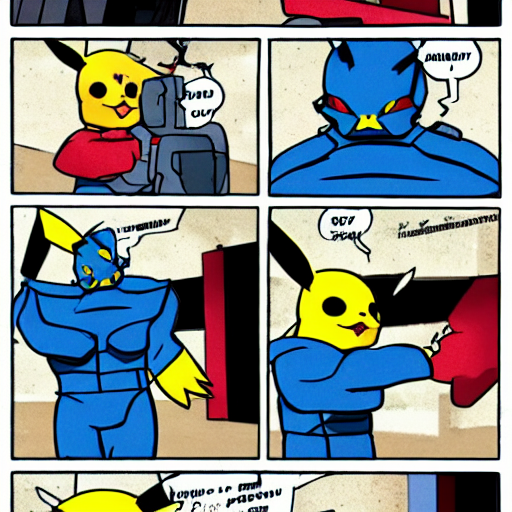Can you describe the style of artwork in this image? This image appears to have adopted a style that closely resembles traditional comic book art, characterized by its bold lines, vivid colors, and dynamic characters. It features a paneled layout typical of comic strips, with speech bubbles indicating dialogue, contributing to storytelling within a single frame or a sequence of frames. What do the color choices in the image suggest about the mood or theme? The color palette emphasizes primary colors like red, blue, and yellow, which are often used in superhero comics to convey vibrancy and energy. Such choices may suggest excitement and action, which are hallmarks of the genre. The mood is thus likely one of adventure and high spirits, helping to engage the reader and bring the scenes to life. 